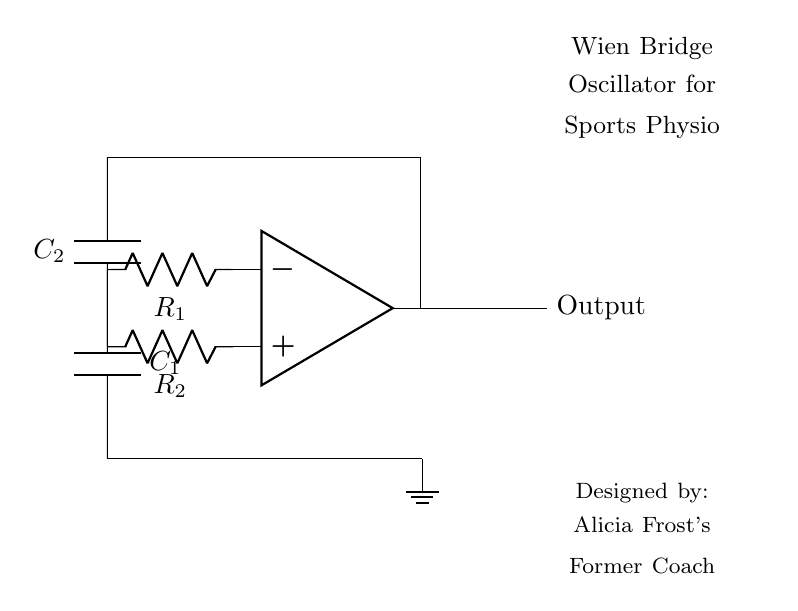What type of oscillator is represented in the diagram? The diagram clearly states that it is a Wien Bridge oscillator, as indicated in the label. This type of oscillator is known for generating sine waves.
Answer: Wien Bridge What are the components connected to the op-amp? The op-amp is connected to two resistors (R1 and R2) and two capacitors (C1 and C2). This is evident in the drawing where the components are directly connected to the op-amp terminals.
Answer: Two resistors and two capacitors What is the function of the resistors in this circuit? The resistors (R1 and R2) in a Wien Bridge oscillator configure the feedback and determine the oscillation frequency, which is essential for sustained sine wave generation.
Answer: Feedback and frequency determination What is the role of the capacitors in the Wien Bridge oscillator? Capacitors (C1 and C2) serve to create phase shifts necessary for the oscillation to occur. They also affect the time constants in the circuit, further contributing to the functioning of the oscillator.
Answer: Create phase shifts Which element provides the output in this circuit? The output is taken from the op-amp's output terminal, as depicted with the label "Output" on the right side of the op-amp. This indicates where the sine wave signal is generated.
Answer: Op-amp output What happens if R1 and R2 are not equal in the circuit? If R1 and R2 are not equal, the balance condition for oscillation won't be met, leading to distortion or cessation of the oscillation. This is fundamental for a Wien Bridge oscillator to operate correctly.
Answer: Distortion or no oscillation 